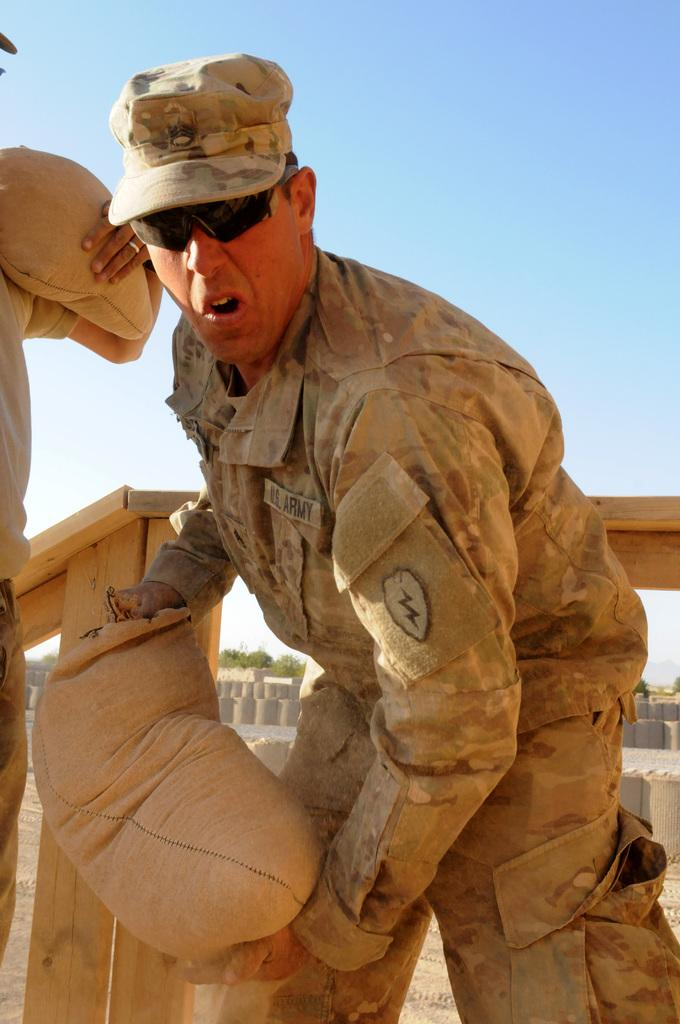How many people are in the image? There are two persons in the image. What are the persons holding in the image? The persons are holding objects. What can be seen in the background of the image? There is a wooden fence and a group of trees visible in the background. What is visible at the top of the image? The sky is visible at the top of the image. What type of vest is the person wearing in the image? There is no vest visible in the image. Can you tell me how many eggnogs are being consumed by the persons in the image? There is no eggnog present in the image. 